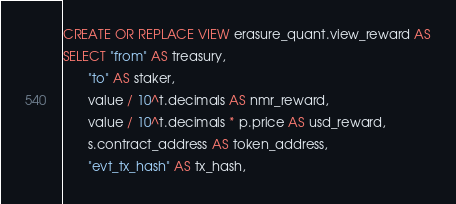<code> <loc_0><loc_0><loc_500><loc_500><_SQL_>CREATE OR REPLACE VIEW erasure_quant.view_reward AS
SELECT "from" AS treasury,
       "to" AS staker,
       value / 10^t.decimals AS nmr_reward,
       value / 10^t.decimals * p.price AS usd_reward,
       s.contract_address AS token_address,
       "evt_tx_hash" AS tx_hash,</code> 